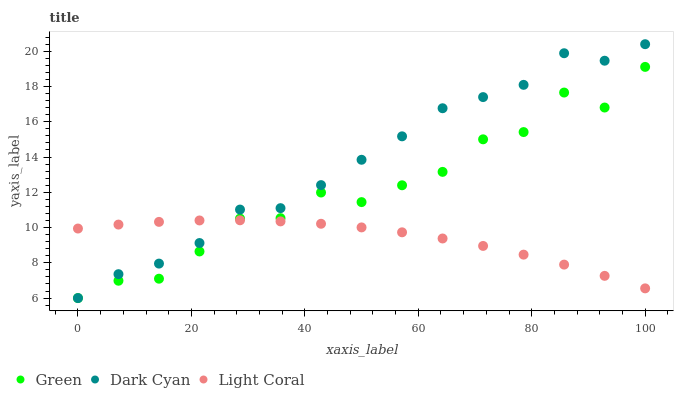Does Light Coral have the minimum area under the curve?
Answer yes or no. Yes. Does Dark Cyan have the maximum area under the curve?
Answer yes or no. Yes. Does Green have the minimum area under the curve?
Answer yes or no. No. Does Green have the maximum area under the curve?
Answer yes or no. No. Is Light Coral the smoothest?
Answer yes or no. Yes. Is Green the roughest?
Answer yes or no. Yes. Is Green the smoothest?
Answer yes or no. No. Is Light Coral the roughest?
Answer yes or no. No. Does Dark Cyan have the lowest value?
Answer yes or no. Yes. Does Light Coral have the lowest value?
Answer yes or no. No. Does Dark Cyan have the highest value?
Answer yes or no. Yes. Does Green have the highest value?
Answer yes or no. No. Does Light Coral intersect Green?
Answer yes or no. Yes. Is Light Coral less than Green?
Answer yes or no. No. Is Light Coral greater than Green?
Answer yes or no. No. 